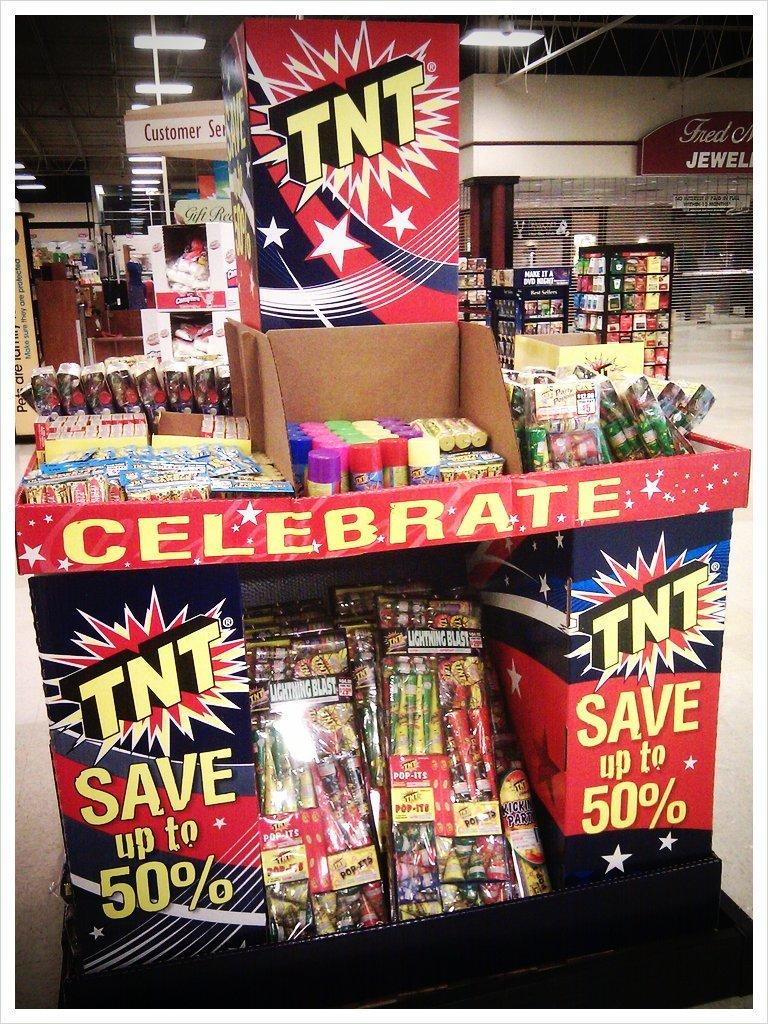Provide a one-sentence caption for the provided image. A TNT firework display with several different kinds of fireworks for sell. 